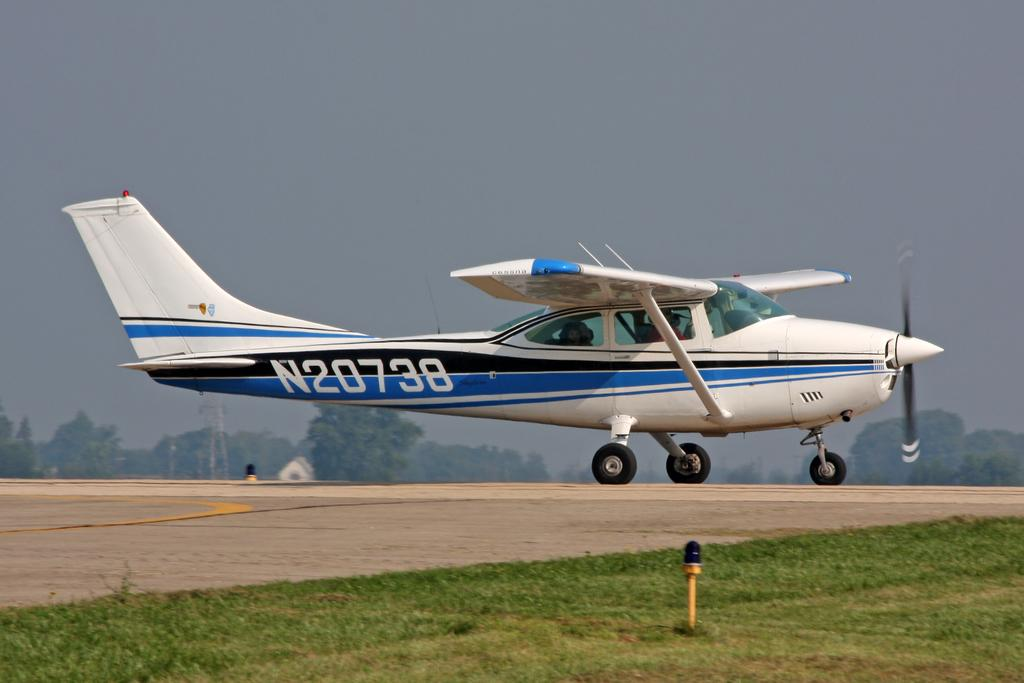<image>
Describe the image concisely. Plane N20738 which is colored blue, black, and white is coming in for a landing. 